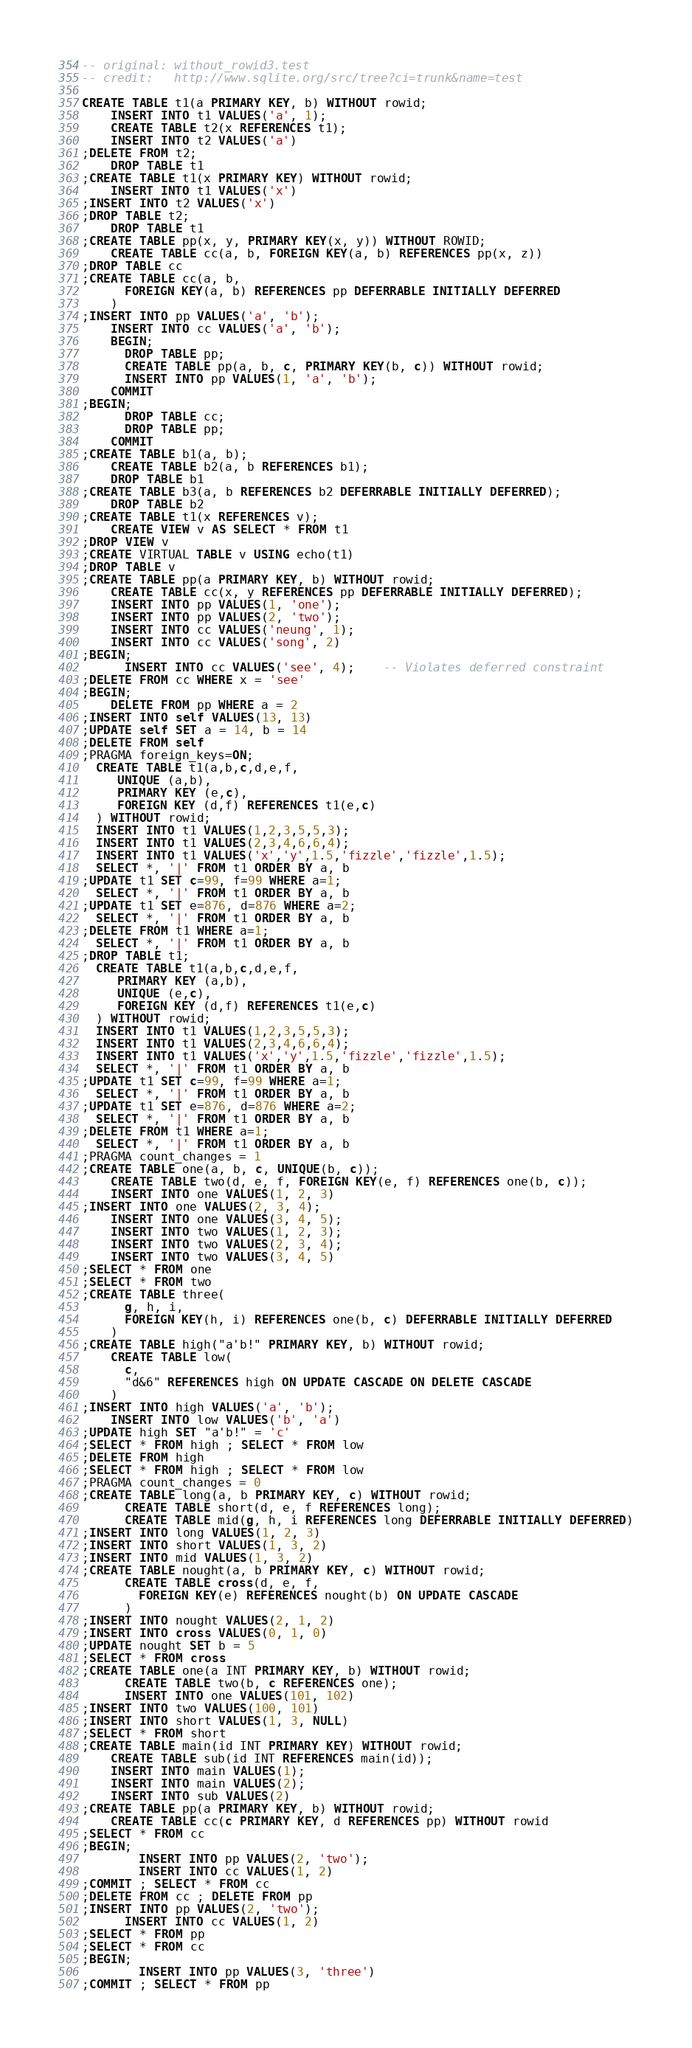<code> <loc_0><loc_0><loc_500><loc_500><_SQL_>-- original: without_rowid3.test
-- credit:   http://www.sqlite.org/src/tree?ci=trunk&name=test

CREATE TABLE t1(a PRIMARY KEY, b) WITHOUT rowid;
    INSERT INTO t1 VALUES('a', 1);
    CREATE TABLE t2(x REFERENCES t1);
    INSERT INTO t2 VALUES('a')
;DELETE FROM t2;
    DROP TABLE t1
;CREATE TABLE t1(x PRIMARY KEY) WITHOUT rowid;
    INSERT INTO t1 VALUES('x')
;INSERT INTO t2 VALUES('x')
;DROP TABLE t2;
    DROP TABLE t1
;CREATE TABLE pp(x, y, PRIMARY KEY(x, y)) WITHOUT ROWID;
    CREATE TABLE cc(a, b, FOREIGN KEY(a, b) REFERENCES pp(x, z))
;DROP TABLE cc
;CREATE TABLE cc(a, b, 
      FOREIGN KEY(a, b) REFERENCES pp DEFERRABLE INITIALLY DEFERRED
    )
;INSERT INTO pp VALUES('a', 'b');
    INSERT INTO cc VALUES('a', 'b');
    BEGIN;
      DROP TABLE pp;
      CREATE TABLE pp(a, b, c, PRIMARY KEY(b, c)) WITHOUT rowid;
      INSERT INTO pp VALUES(1, 'a', 'b');
    COMMIT
;BEGIN;
      DROP TABLE cc;
      DROP TABLE pp;
    COMMIT
;CREATE TABLE b1(a, b);
    CREATE TABLE b2(a, b REFERENCES b1);
    DROP TABLE b1
;CREATE TABLE b3(a, b REFERENCES b2 DEFERRABLE INITIALLY DEFERRED);
    DROP TABLE b2
;CREATE TABLE t1(x REFERENCES v); 
    CREATE VIEW v AS SELECT * FROM t1
;DROP VIEW v
;CREATE VIRTUAL TABLE v USING echo(t1)
;DROP TABLE v
;CREATE TABLE pp(a PRIMARY KEY, b) WITHOUT rowid;
    CREATE TABLE cc(x, y REFERENCES pp DEFERRABLE INITIALLY DEFERRED);
    INSERT INTO pp VALUES(1, 'one');
    INSERT INTO pp VALUES(2, 'two');
    INSERT INTO cc VALUES('neung', 1);
    INSERT INTO cc VALUES('song', 2)
;BEGIN;
      INSERT INTO cc VALUES('see', 4);    -- Violates deferred constraint
;DELETE FROM cc WHERE x = 'see'
;BEGIN;
    DELETE FROM pp WHERE a = 2
;INSERT INTO self VALUES(13, 13)
;UPDATE self SET a = 14, b = 14
;DELETE FROM self
;PRAGMA foreign_keys=ON;
  CREATE TABLE t1(a,b,c,d,e,f,
     UNIQUE (a,b),
     PRIMARY KEY (e,c),
     FOREIGN KEY (d,f) REFERENCES t1(e,c)
  ) WITHOUT rowid;
  INSERT INTO t1 VALUES(1,2,3,5,5,3);
  INSERT INTO t1 VALUES(2,3,4,6,6,4);
  INSERT INTO t1 VALUES('x','y',1.5,'fizzle','fizzle',1.5);
  SELECT *, '|' FROM t1 ORDER BY a, b
;UPDATE t1 SET c=99, f=99 WHERE a=1;
  SELECT *, '|' FROM t1 ORDER BY a, b
;UPDATE t1 SET e=876, d=876 WHERE a=2;
  SELECT *, '|' FROM t1 ORDER BY a, b
;DELETE FROM t1 WHERE a=1;
  SELECT *, '|' FROM t1 ORDER BY a, b
;DROP TABLE t1;
  CREATE TABLE t1(a,b,c,d,e,f,
     PRIMARY KEY (a,b),
     UNIQUE (e,c),
     FOREIGN KEY (d,f) REFERENCES t1(e,c)
  ) WITHOUT rowid;
  INSERT INTO t1 VALUES(1,2,3,5,5,3);
  INSERT INTO t1 VALUES(2,3,4,6,6,4);
  INSERT INTO t1 VALUES('x','y',1.5,'fizzle','fizzle',1.5);
  SELECT *, '|' FROM t1 ORDER BY a, b
;UPDATE t1 SET c=99, f=99 WHERE a=1;
  SELECT *, '|' FROM t1 ORDER BY a, b
;UPDATE t1 SET e=876, d=876 WHERE a=2;
  SELECT *, '|' FROM t1 ORDER BY a, b
;DELETE FROM t1 WHERE a=1;
  SELECT *, '|' FROM t1 ORDER BY a, b
;PRAGMA count_changes = 1
;CREATE TABLE one(a, b, c, UNIQUE(b, c));
    CREATE TABLE two(d, e, f, FOREIGN KEY(e, f) REFERENCES one(b, c));
    INSERT INTO one VALUES(1, 2, 3)
;INSERT INTO one VALUES(2, 3, 4);
    INSERT INTO one VALUES(3, 4, 5);
    INSERT INTO two VALUES(1, 2, 3);
    INSERT INTO two VALUES(2, 3, 4);
    INSERT INTO two VALUES(3, 4, 5)
;SELECT * FROM one
;SELECT * FROM two
;CREATE TABLE three(
      g, h, i, 
      FOREIGN KEY(h, i) REFERENCES one(b, c) DEFERRABLE INITIALLY DEFERRED
    )
;CREATE TABLE high("a'b!" PRIMARY KEY, b) WITHOUT rowid;
    CREATE TABLE low(
      c, 
      "d&6" REFERENCES high ON UPDATE CASCADE ON DELETE CASCADE
    )
;INSERT INTO high VALUES('a', 'b');
    INSERT INTO low VALUES('b', 'a')
;UPDATE high SET "a'b!" = 'c'
;SELECT * FROM high ; SELECT * FROM low
;DELETE FROM high
;SELECT * FROM high ; SELECT * FROM low
;PRAGMA count_changes = 0
;CREATE TABLE long(a, b PRIMARY KEY, c) WITHOUT rowid;
      CREATE TABLE short(d, e, f REFERENCES long);
      CREATE TABLE mid(g, h, i REFERENCES long DEFERRABLE INITIALLY DEFERRED)
;INSERT INTO long VALUES(1, 2, 3)
;INSERT INTO short VALUES(1, 3, 2)
;INSERT INTO mid VALUES(1, 3, 2)
;CREATE TABLE nought(a, b PRIMARY KEY, c) WITHOUT rowid;
      CREATE TABLE cross(d, e, f,
        FOREIGN KEY(e) REFERENCES nought(b) ON UPDATE CASCADE
      )
;INSERT INTO nought VALUES(2, 1, 2)
;INSERT INTO cross VALUES(0, 1, 0)
;UPDATE nought SET b = 5
;SELECT * FROM cross
;CREATE TABLE one(a INT PRIMARY KEY, b) WITHOUT rowid;
      CREATE TABLE two(b, c REFERENCES one);
      INSERT INTO one VALUES(101, 102)
;INSERT INTO two VALUES(100, 101)
;INSERT INTO short VALUES(1, 3, NULL)
;SELECT * FROM short
;CREATE TABLE main(id INT PRIMARY KEY) WITHOUT rowid;
    CREATE TABLE sub(id INT REFERENCES main(id));
    INSERT INTO main VALUES(1);
    INSERT INTO main VALUES(2);
    INSERT INTO sub VALUES(2)
;CREATE TABLE pp(a PRIMARY KEY, b) WITHOUT rowid;
    CREATE TABLE cc(c PRIMARY KEY, d REFERENCES pp) WITHOUT rowid
;SELECT * FROM cc
;BEGIN;
        INSERT INTO pp VALUES(2, 'two');
        INSERT INTO cc VALUES(1, 2)
;COMMIT ; SELECT * FROM cc
;DELETE FROM cc ; DELETE FROM pp
;INSERT INTO pp VALUES(2, 'two');
      INSERT INTO cc VALUES(1, 2)
;SELECT * FROM pp
;SELECT * FROM cc
;BEGIN;
        INSERT INTO pp VALUES(3, 'three')
;COMMIT ; SELECT * FROM pp</code> 